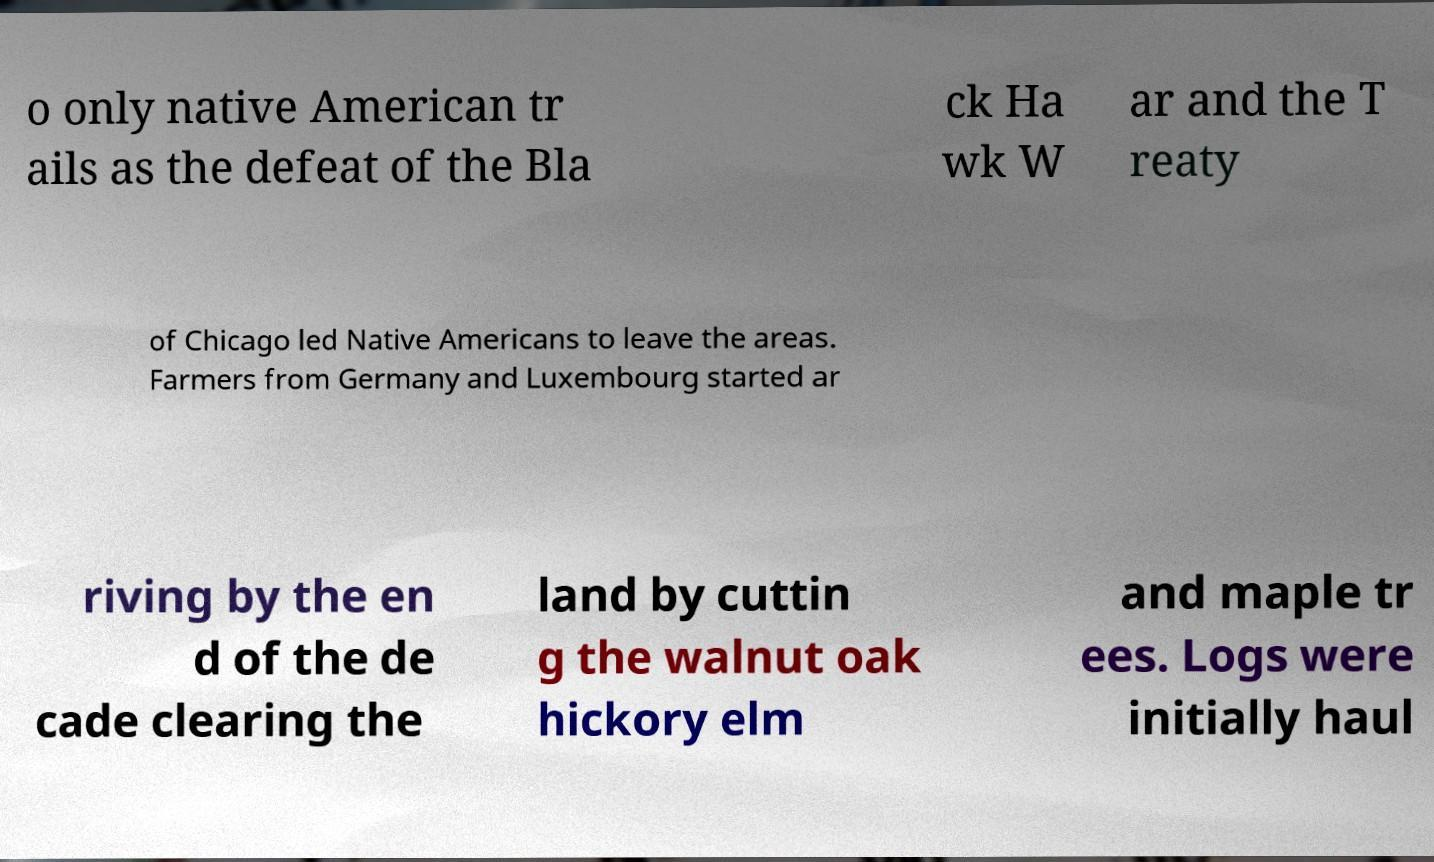Can you read and provide the text displayed in the image?This photo seems to have some interesting text. Can you extract and type it out for me? o only native American tr ails as the defeat of the Bla ck Ha wk W ar and the T reaty of Chicago led Native Americans to leave the areas. Farmers from Germany and Luxembourg started ar riving by the en d of the de cade clearing the land by cuttin g the walnut oak hickory elm and maple tr ees. Logs were initially haul 